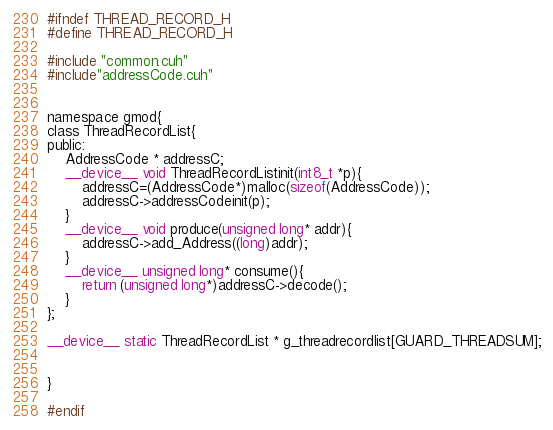<code> <loc_0><loc_0><loc_500><loc_500><_Cuda_>

#ifndef THREAD_RECORD_H
#define THREAD_RECORD_H

#include "common.cuh"
#include"addressCode.cuh"


namespace gmod{
class ThreadRecordList{
public:
	AddressCode * addressC;
	__device__ void ThreadRecordListinit(int8_t *p){
		addressC=(AddressCode*)malloc(sizeof(AddressCode));
		addressC->addressCodeinit(p);
	}
	__device__ void produce(unsigned long* addr){
		addressC->add_Address((long)addr);
	}
	__device__ unsigned long* consume(){
		return (unsigned long*)addressC->decode();
	}
};

__device__ static ThreadRecordList * g_threadrecordlist[GUARD_THREADSUM];


}

#endif
</code> 